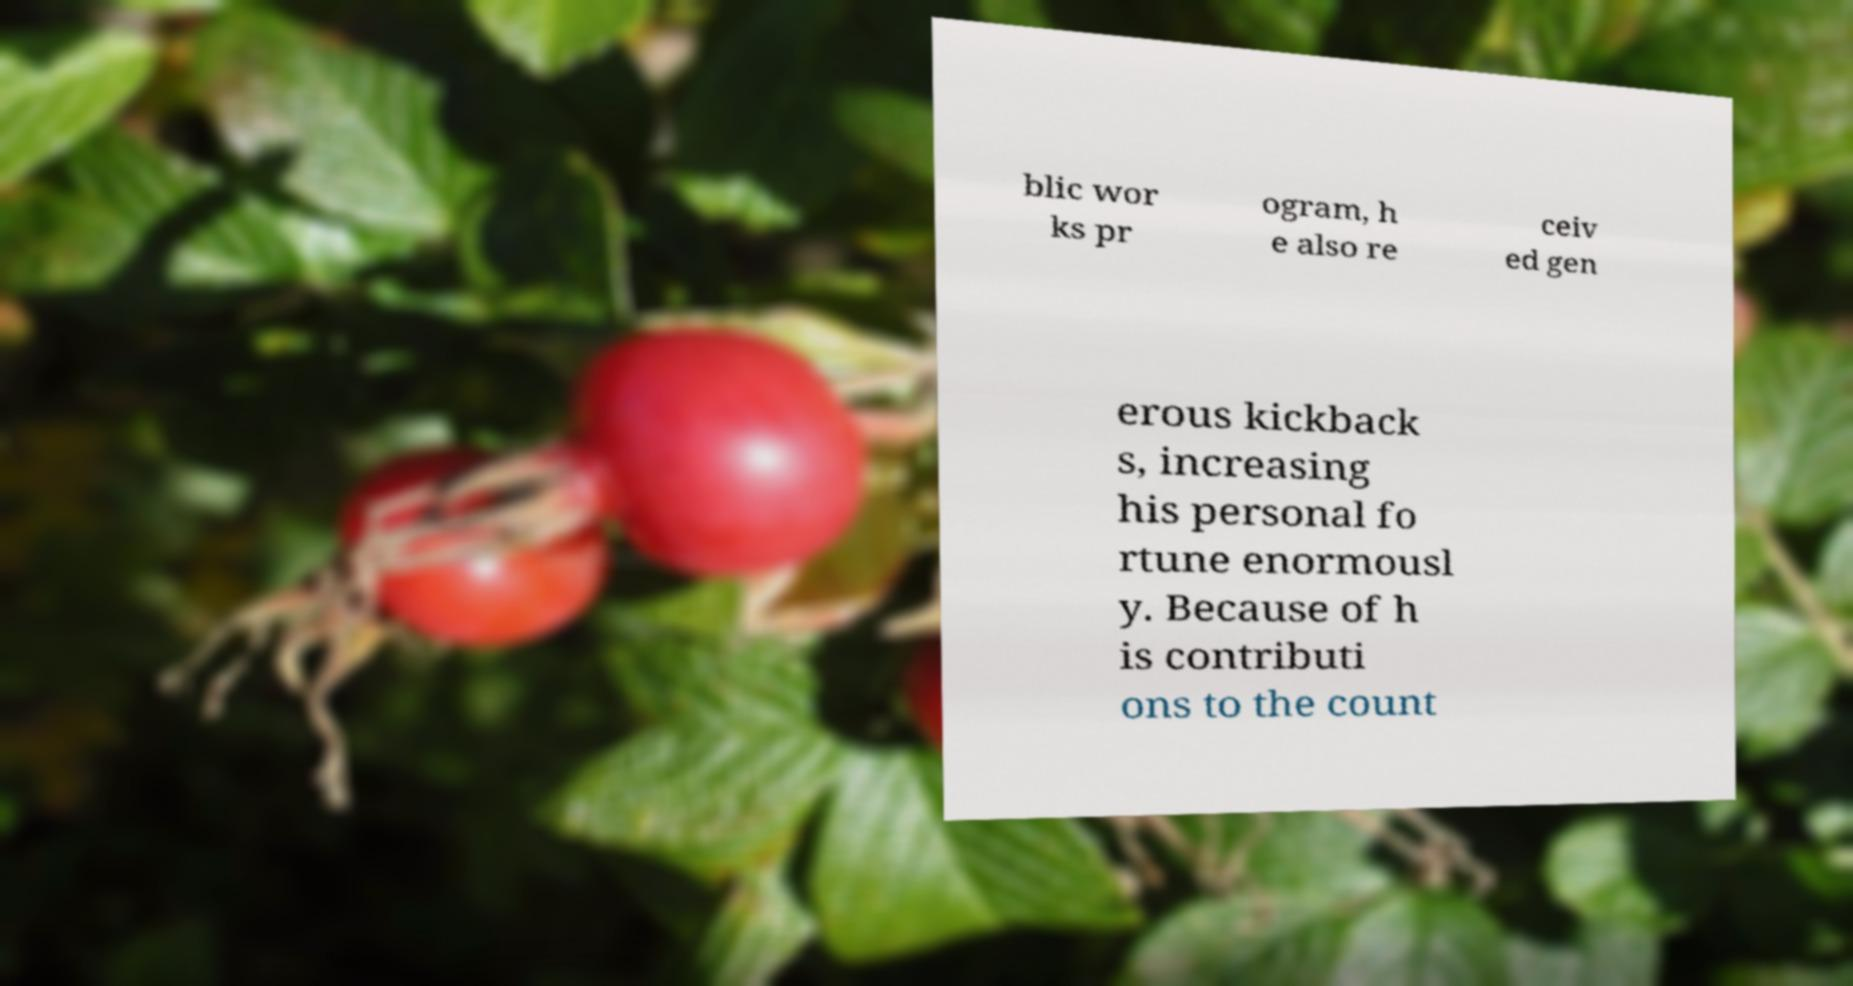There's text embedded in this image that I need extracted. Can you transcribe it verbatim? blic wor ks pr ogram, h e also re ceiv ed gen erous kickback s, increasing his personal fo rtune enormousl y. Because of h is contributi ons to the count 